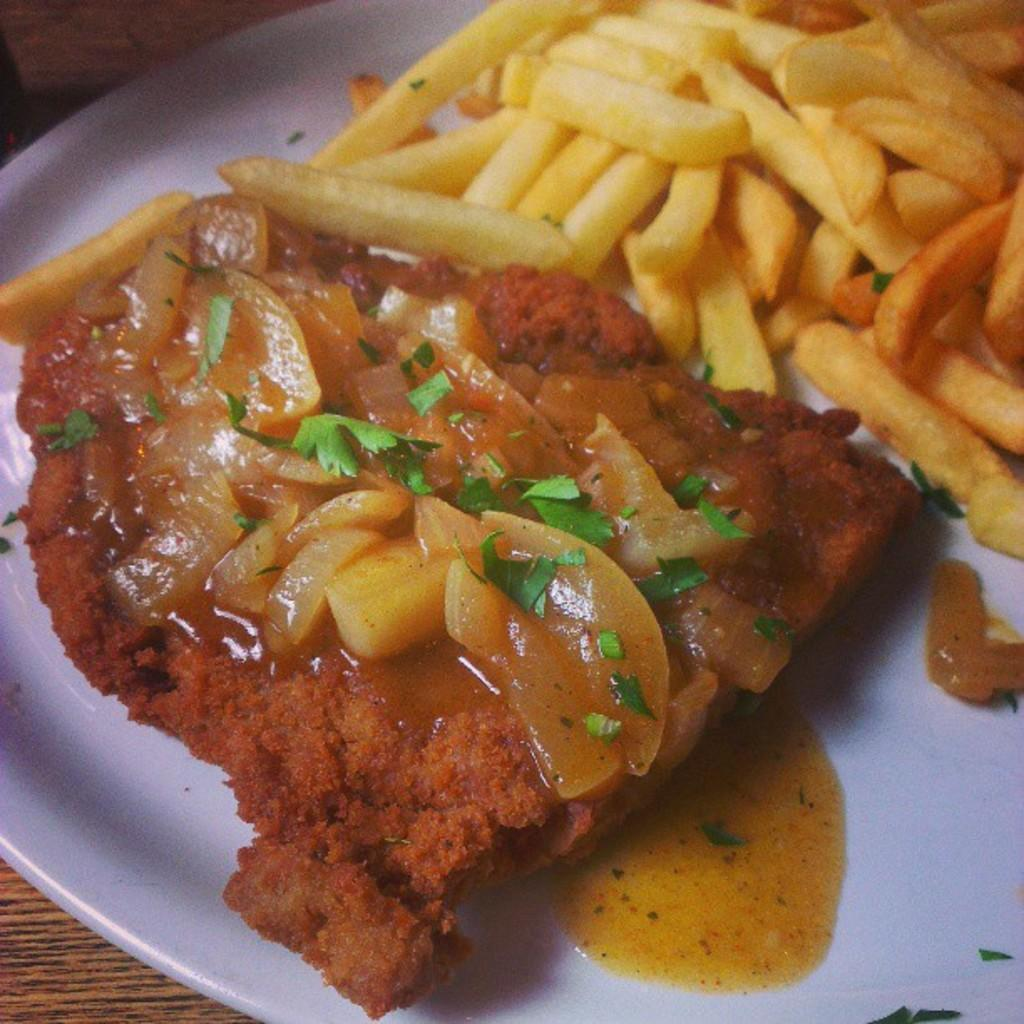What is on the plate that is visible in the image? The plate contains french fries, chopped onions, and coriander leaves. What type of food item can be seen on the plate? There is a food item on the plate, but it is not specified in the facts. What is the material of the table in the image? The table appears to be made of wood. What degree of inflation is causing the balloon to float in the image? There is no balloon present in the image, so it is not possible to determine the degree of inflation causing it to float. 